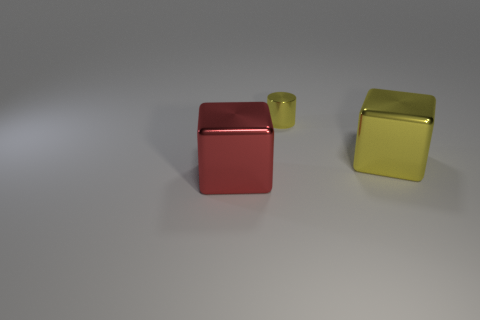Add 2 blue shiny things. How many objects exist? 5 Subtract all cylinders. How many objects are left? 2 Add 1 yellow shiny blocks. How many yellow shiny blocks are left? 2 Add 3 small cylinders. How many small cylinders exist? 4 Subtract 0 blue cylinders. How many objects are left? 3 Subtract all large red blocks. Subtract all small green rubber balls. How many objects are left? 2 